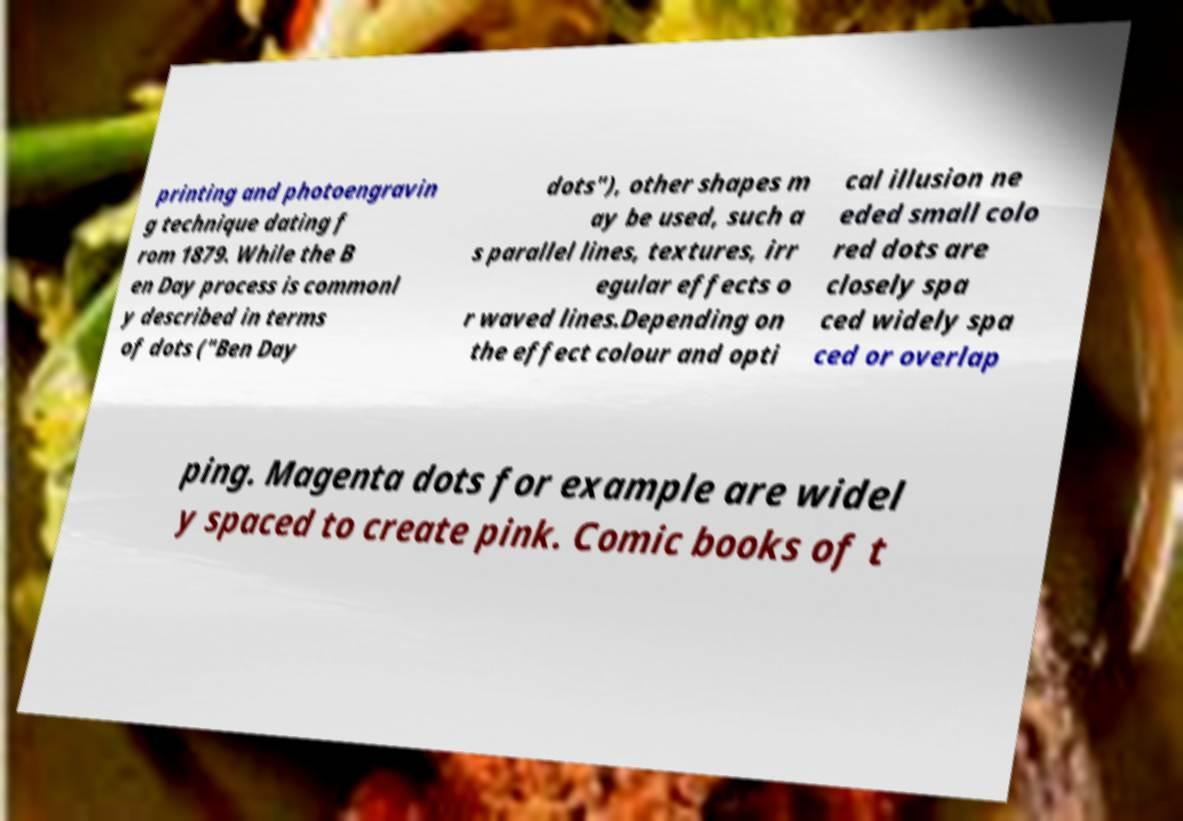For documentation purposes, I need the text within this image transcribed. Could you provide that? printing and photoengravin g technique dating f rom 1879. While the B en Day process is commonl y described in terms of dots ("Ben Day dots"), other shapes m ay be used, such a s parallel lines, textures, irr egular effects o r waved lines.Depending on the effect colour and opti cal illusion ne eded small colo red dots are closely spa ced widely spa ced or overlap ping. Magenta dots for example are widel y spaced to create pink. Comic books of t 